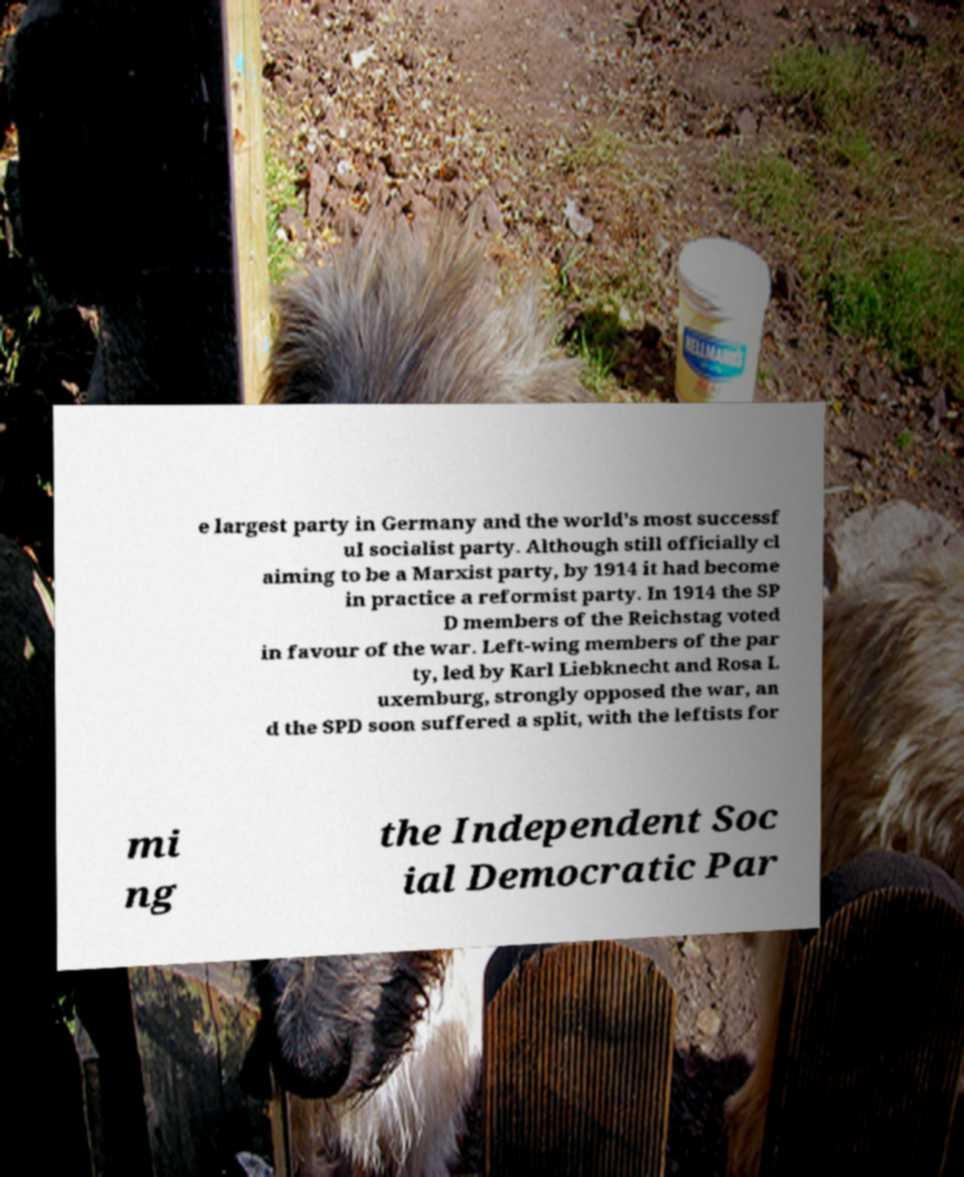Please identify and transcribe the text found in this image. e largest party in Germany and the world's most successf ul socialist party. Although still officially cl aiming to be a Marxist party, by 1914 it had become in practice a reformist party. In 1914 the SP D members of the Reichstag voted in favour of the war. Left-wing members of the par ty, led by Karl Liebknecht and Rosa L uxemburg, strongly opposed the war, an d the SPD soon suffered a split, with the leftists for mi ng the Independent Soc ial Democratic Par 